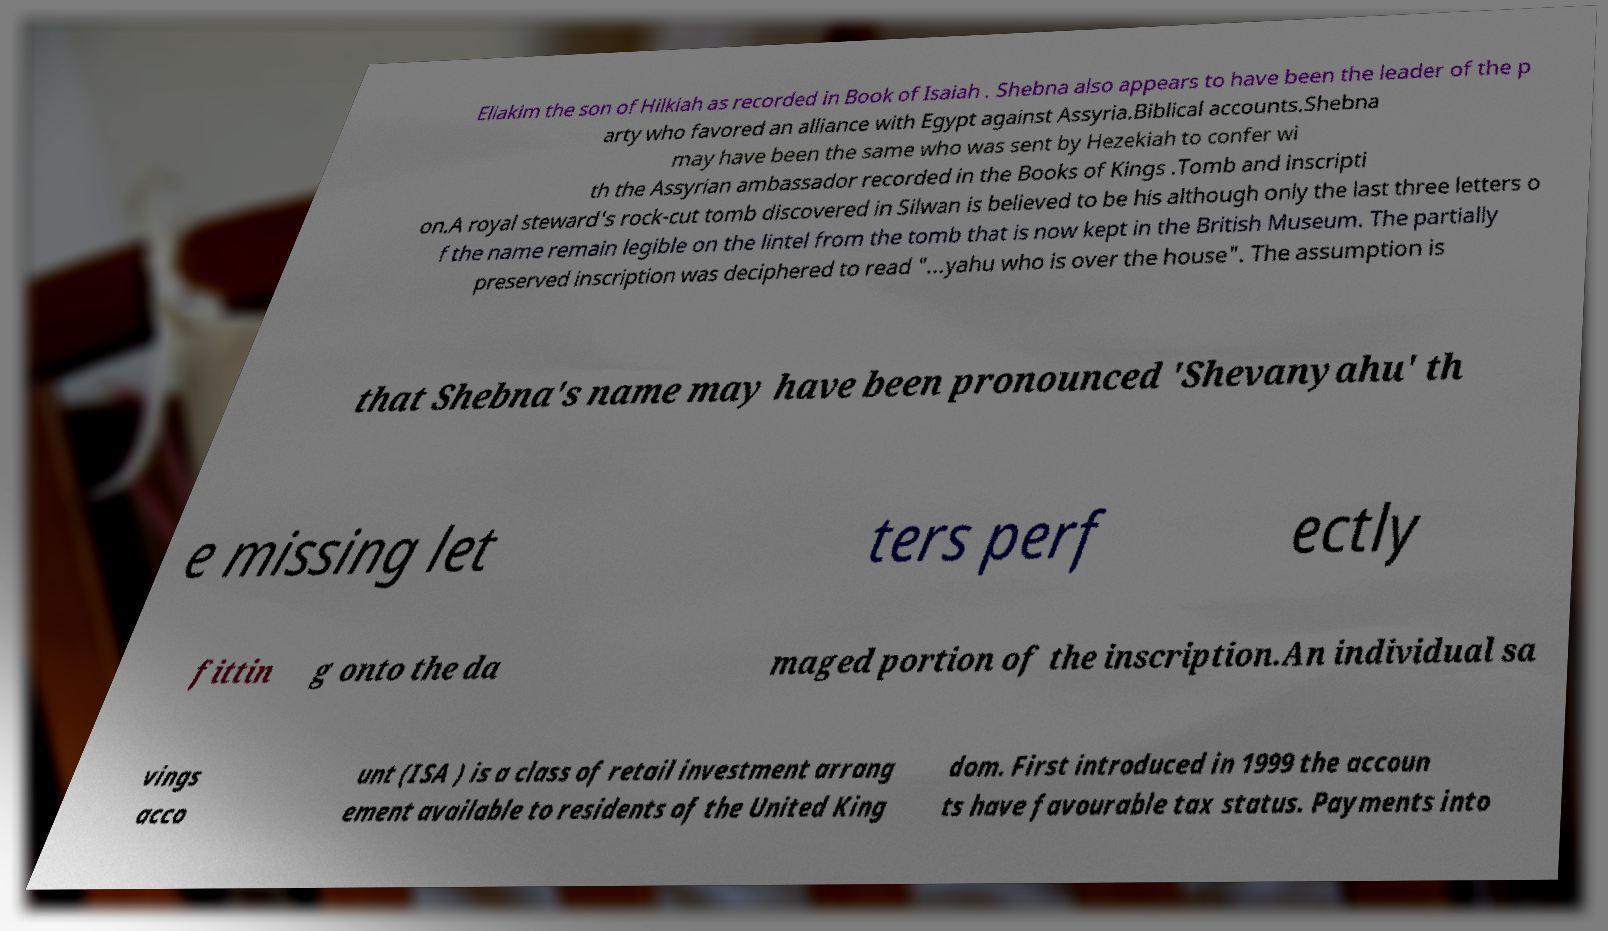Please read and relay the text visible in this image. What does it say? Eliakim the son of Hilkiah as recorded in Book of Isaiah . Shebna also appears to have been the leader of the p arty who favored an alliance with Egypt against Assyria.Biblical accounts.Shebna may have been the same who was sent by Hezekiah to confer wi th the Assyrian ambassador recorded in the Books of Kings .Tomb and inscripti on.A royal steward's rock-cut tomb discovered in Silwan is believed to be his although only the last three letters o f the name remain legible on the lintel from the tomb that is now kept in the British Museum. The partially preserved inscription was deciphered to read "...yahu who is over the house". The assumption is that Shebna's name may have been pronounced 'Shevanyahu' th e missing let ters perf ectly fittin g onto the da maged portion of the inscription.An individual sa vings acco unt (ISA ) is a class of retail investment arrang ement available to residents of the United King dom. First introduced in 1999 the accoun ts have favourable tax status. Payments into 